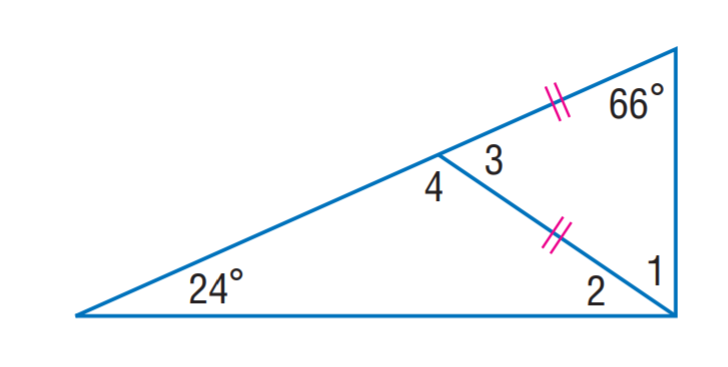Answer the mathemtical geometry problem and directly provide the correct option letter.
Question: Find m \angle 1.
Choices: A: 24 B: 54 C: 66 D: 78 C 